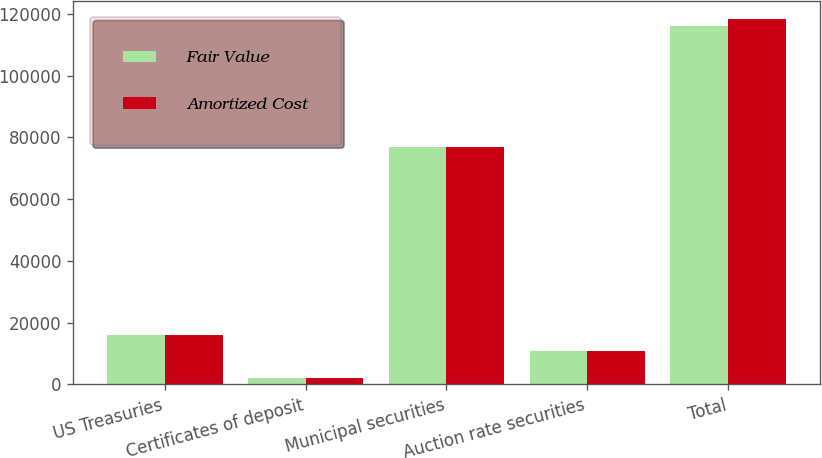Convert chart to OTSL. <chart><loc_0><loc_0><loc_500><loc_500><stacked_bar_chart><ecel><fcel>US Treasuries<fcel>Certificates of deposit<fcel>Municipal securities<fcel>Auction rate securities<fcel>Total<nl><fcel>Fair Value<fcel>16040<fcel>2201<fcel>77038<fcel>10748<fcel>115952<nl><fcel>Amortized Cost<fcel>16040<fcel>2201<fcel>77027<fcel>10748<fcel>118424<nl></chart> 